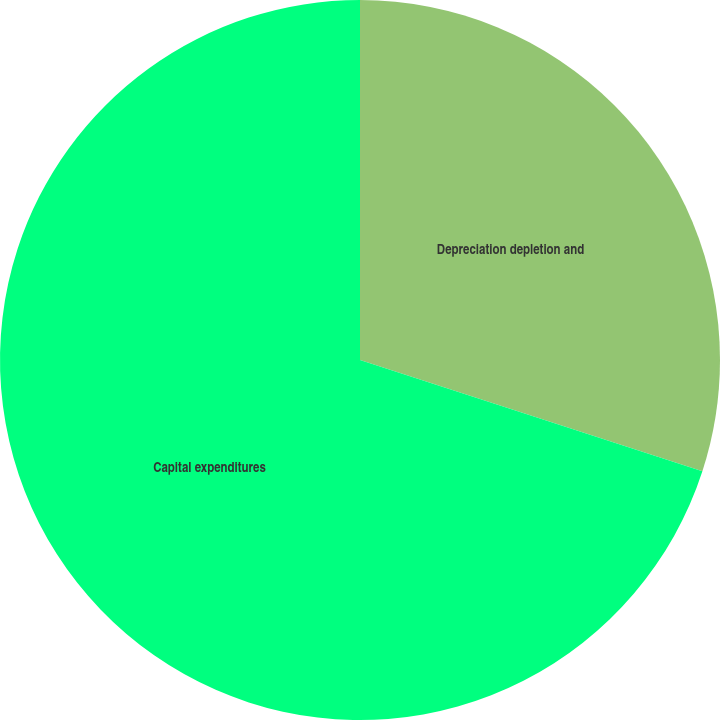Convert chart. <chart><loc_0><loc_0><loc_500><loc_500><pie_chart><fcel>Depreciation depletion and<fcel>Capital expenditures<nl><fcel>30.0%<fcel>70.0%<nl></chart> 